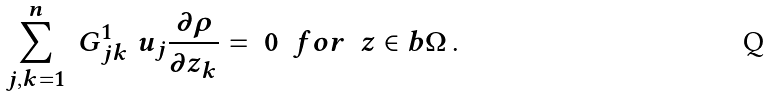<formula> <loc_0><loc_0><loc_500><loc_500>\sum _ { j , k = 1 } ^ { n } \ G ^ { 1 } _ { j k } \ u _ { j } \frac { \partial \rho } { \partial z _ { k } } = \ 0 \ \ f o r \ \ z \in b \Omega \, .</formula> 